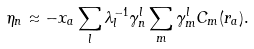Convert formula to latex. <formula><loc_0><loc_0><loc_500><loc_500>\eta _ { n } \approx - x _ { a } \sum _ { l } \lambda ^ { - 1 } _ { l } \gamma ^ { l } _ { n } \sum _ { m } \gamma ^ { l } _ { m } C _ { m } ( { r } _ { a } ) .</formula> 